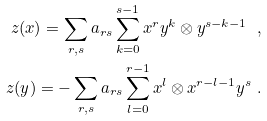Convert formula to latex. <formula><loc_0><loc_0><loc_500><loc_500>z ( x ) = \sum _ { r , s } a _ { r s } \sum _ { k = 0 } ^ { s - 1 } x ^ { r } y ^ { k } \otimes y ^ { s - k - 1 } \ , \\ z ( y ) = - \sum _ { r , s } a _ { r s } \sum _ { l = 0 } ^ { r - 1 } x ^ { l } \otimes x ^ { r - l - 1 } y ^ { s } \ .</formula> 